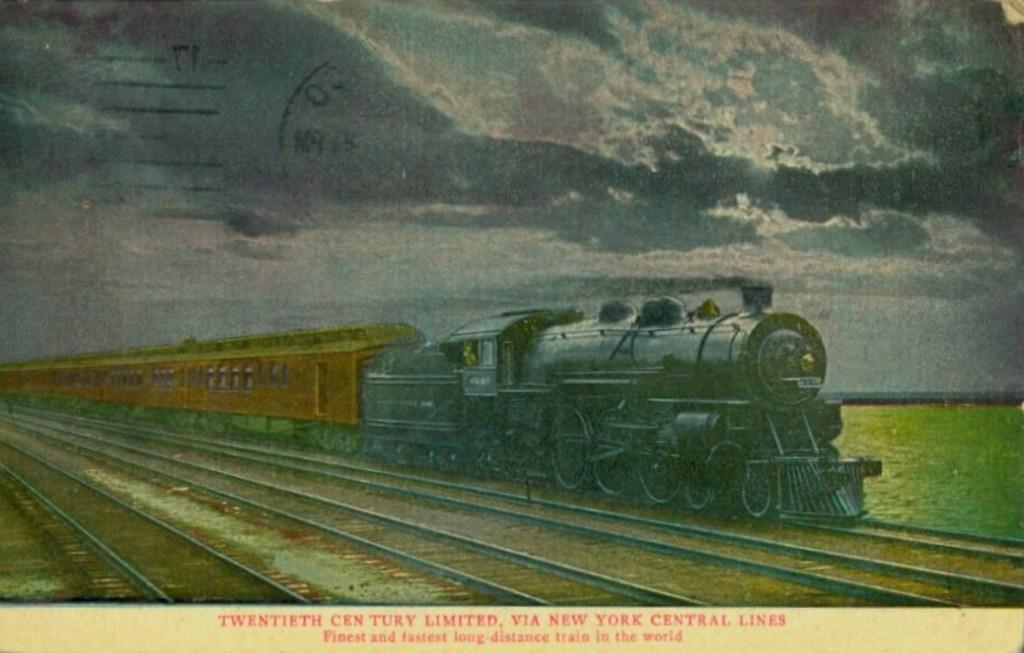What can be seen on one of the tracks in the image? There is a train on one of the tracks in the image. What natural element is visible in the image? Water is visible in the image. What is present in the sky in the image? There are clouds in the sky in the image. Where can text be found in the image? Text can be found at the bottom of the photo. How many cent beetles are crawling on the train in the image? There are no beetles, cent or otherwise, present on the train in the image. 